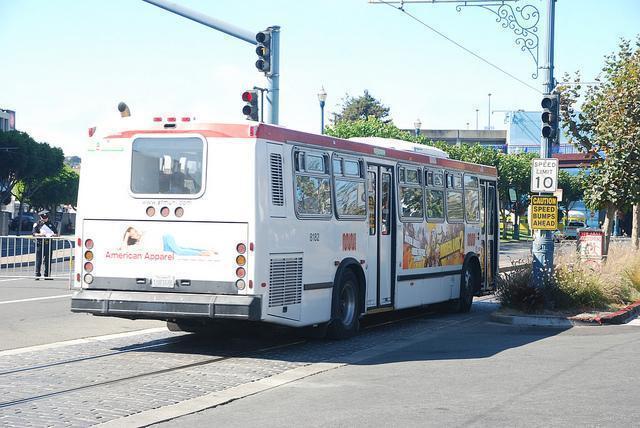Where is the bus located?
Answer the question by selecting the correct answer among the 4 following choices and explain your choice with a short sentence. The answer should be formatted with the following format: `Answer: choice
Rationale: rationale.`
Options: Bus lane, crosswalk, bike path, dog path. Answer: bus lane.
Rationale: The bus is in a lane. 